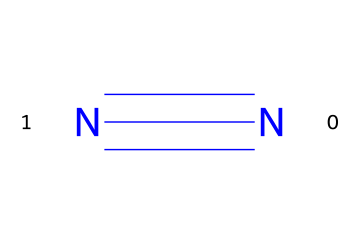What is the molecular formula for this substance? The SMILES representation shows two nitrogen atoms connected by a triple bond, which indicates that the molecular formula is N2.
Answer: N2 How many bonds are present in the molecule? The representation indicates a triple bond between the two nitrogen atoms, which counts as three bonds.
Answer: 3 What type of gas is nitrogen classified as? Nitrogen gas is classified as a diatomic gas since it consists of two nitrogen atoms.
Answer: diatomic What is the bond order of the nitrogen-nitrogen bond? A triple bond represents a bond order of 3, which is the number of bonding interactions between the two nitrogen atoms.
Answer: 3 Is nitrogen gas flammable? Nitrogen gas is inert and does not support combustion, which means it is not flammable.
Answer: not flammable What role does nitrogen play in basketball inflation? Nitrogen is used in basketball inflation as it is less likely to expand or contract with temperature changes compared to air.
Answer: stability 